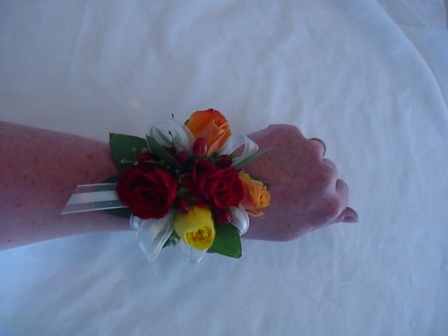Can you describe the mood of the image and what kind of event the person might be attending? The image conveys a serene and celebratory mood, largely due to the presence of the elegant corsage. The use of vibrant colors, coupled with the delicate ribbons and fresh green leaves, suggests a joyous occasion. The person is likely attending a special event such as a prom, wedding, or possibly a formal banquet. During such events, corsages are worn to complement formal attire and signify participation in a memorable or festive occasion. 